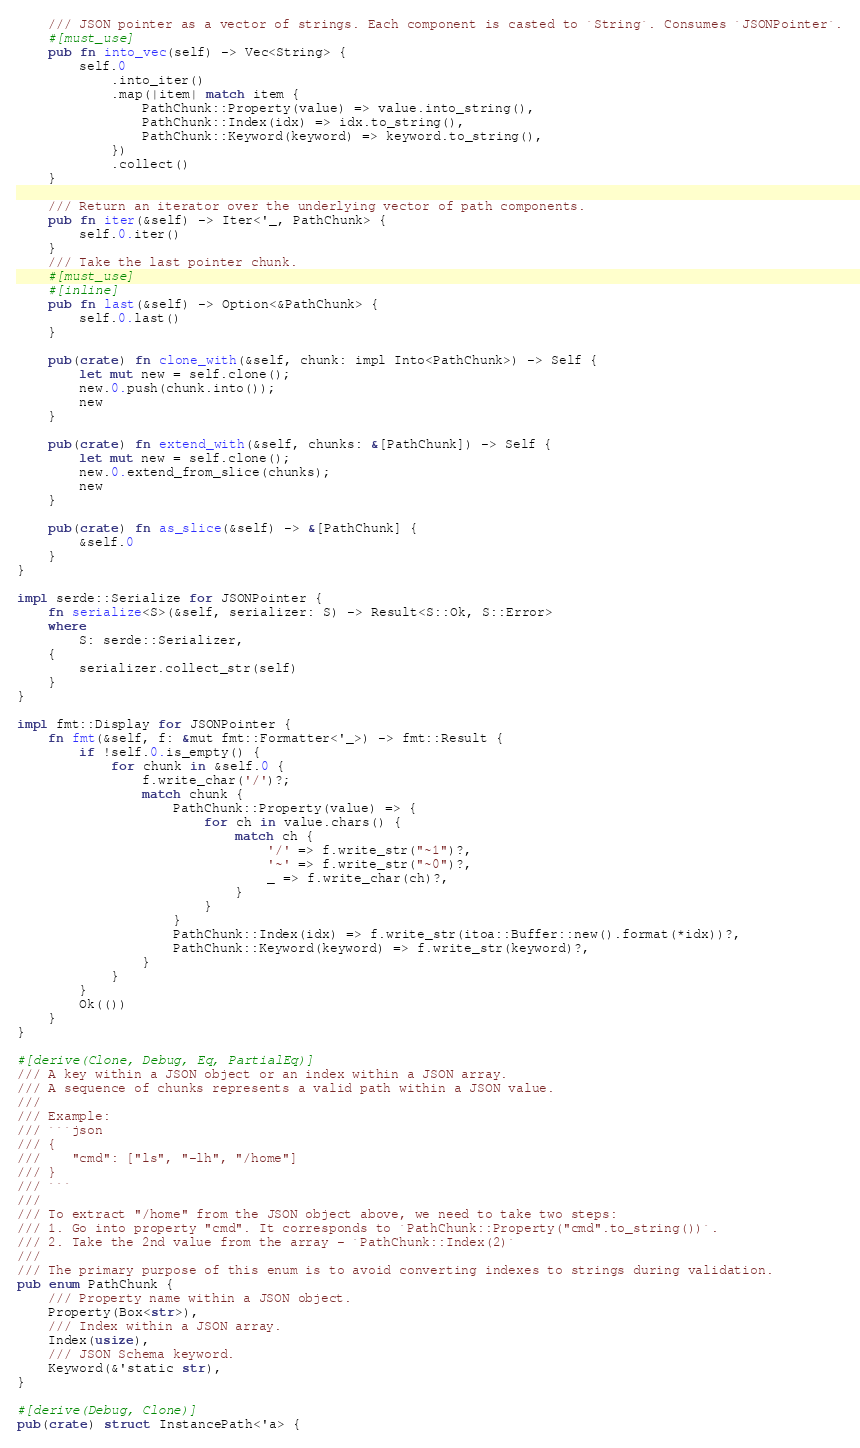Convert code to text. <code><loc_0><loc_0><loc_500><loc_500><_Rust_>    /// JSON pointer as a vector of strings. Each component is casted to `String`. Consumes `JSONPointer`.
    #[must_use]
    pub fn into_vec(self) -> Vec<String> {
        self.0
            .into_iter()
            .map(|item| match item {
                PathChunk::Property(value) => value.into_string(),
                PathChunk::Index(idx) => idx.to_string(),
                PathChunk::Keyword(keyword) => keyword.to_string(),
            })
            .collect()
    }

    /// Return an iterator over the underlying vector of path components.
    pub fn iter(&self) -> Iter<'_, PathChunk> {
        self.0.iter()
    }
    /// Take the last pointer chunk.
    #[must_use]
    #[inline]
    pub fn last(&self) -> Option<&PathChunk> {
        self.0.last()
    }

    pub(crate) fn clone_with(&self, chunk: impl Into<PathChunk>) -> Self {
        let mut new = self.clone();
        new.0.push(chunk.into());
        new
    }

    pub(crate) fn extend_with(&self, chunks: &[PathChunk]) -> Self {
        let mut new = self.clone();
        new.0.extend_from_slice(chunks);
        new
    }

    pub(crate) fn as_slice(&self) -> &[PathChunk] {
        &self.0
    }
}

impl serde::Serialize for JSONPointer {
    fn serialize<S>(&self, serializer: S) -> Result<S::Ok, S::Error>
    where
        S: serde::Serializer,
    {
        serializer.collect_str(self)
    }
}

impl fmt::Display for JSONPointer {
    fn fmt(&self, f: &mut fmt::Formatter<'_>) -> fmt::Result {
        if !self.0.is_empty() {
            for chunk in &self.0 {
                f.write_char('/')?;
                match chunk {
                    PathChunk::Property(value) => {
                        for ch in value.chars() {
                            match ch {
                                '/' => f.write_str("~1")?,
                                '~' => f.write_str("~0")?,
                                _ => f.write_char(ch)?,
                            }
                        }
                    }
                    PathChunk::Index(idx) => f.write_str(itoa::Buffer::new().format(*idx))?,
                    PathChunk::Keyword(keyword) => f.write_str(keyword)?,
                }
            }
        }
        Ok(())
    }
}

#[derive(Clone, Debug, Eq, PartialEq)]
/// A key within a JSON object or an index within a JSON array.
/// A sequence of chunks represents a valid path within a JSON value.
///
/// Example:
/// ```json
/// {
///    "cmd": ["ls", "-lh", "/home"]
/// }
/// ```
///
/// To extract "/home" from the JSON object above, we need to take two steps:
/// 1. Go into property "cmd". It corresponds to `PathChunk::Property("cmd".to_string())`.
/// 2. Take the 2nd value from the array - `PathChunk::Index(2)`
///
/// The primary purpose of this enum is to avoid converting indexes to strings during validation.
pub enum PathChunk {
    /// Property name within a JSON object.
    Property(Box<str>),
    /// Index within a JSON array.
    Index(usize),
    /// JSON Schema keyword.
    Keyword(&'static str),
}

#[derive(Debug, Clone)]
pub(crate) struct InstancePath<'a> {</code> 